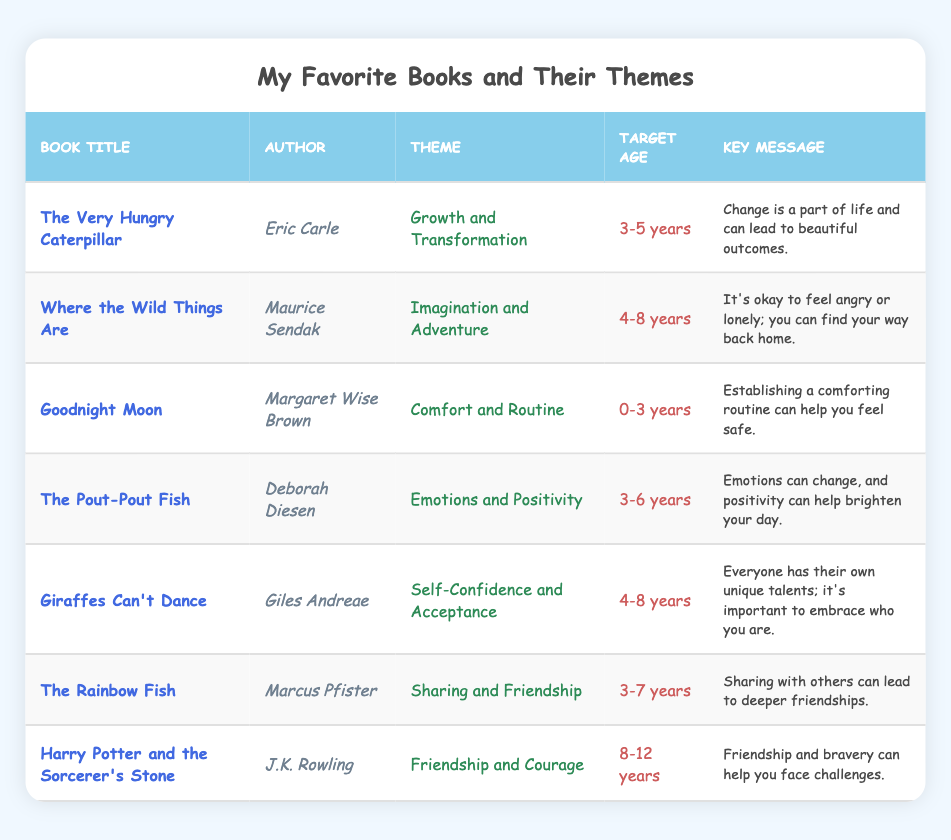What is the theme of "The Very Hungry Caterpillar"? The theme of "The Very Hungry Caterpillar" is found in the "Theme" column next to its title. It states "Growth and Transformation."
Answer: Growth and Transformation Who is the author of "Harry Potter and the Sorcerer's Stone"? To find the author, look at the row for "Harry Potter and the Sorcerer's Stone" and read the "Author" column, which shows "J.K. Rowling."
Answer: J.K. Rowling How many books are targeted for the age range of 4-8 years? By counting the rows that list "4-8 years" under the "Target Age" column, there are three books: "Where the Wild Things Are," "Giraffes Can't Dance," and "Harry Potter and the Sorcerer's Stone."
Answer: 3 Is the key message of "The Pout-Pout Fish" about sadness? The key message for "The Pout-Pout Fish" mentions positivity and changing emotions. It does not say sadness is the focus, so the answer is no.
Answer: No Which book has the theme of "Sharing and Friendship"? The row that mentions "Sharing and Friendship" in the "Theme" column corresponds to "The Rainbow Fish" in the "Book Title" column.
Answer: The Rainbow Fish What is the average target age of the books listed? To find the average, convert the target ages into numerical form (0-3 years = 1.5, 3-5 years = 4, 3-6 years = 4.5, 4-8 years = 6, 3-7 years = 5, 8-12 years = 10) and sum them: 1.5 + 4 + 4.5 + 4.5 + 6 + 5 + 10 = 36. Divide this by 7 (the number of books): 36 / 7 = 5.14 (approximately 5).
Answer: 5 Is "Goodnight Moon" aimed at children older than 3 years? The target age for "Goodnight Moon" is "0-3 years." Since it is not aimed at children older than 3, the answer is no.
Answer: No What books focus on emotions? To find books focusing on emotions, check the "Theme" column for mentions like "Emotions and Positivity." The relevant book is "The Pout-Pout Fish."
Answer: The Pout-Pout Fish How are the themes of "The Rainbow Fish" and "Giraffes Can't Dance" similar? Both books emphasize positive social interactions; "The Rainbow Fish" teaches about friendship through sharing, while "Giraffes Can't Dance" focuses on self-acceptance and confidence, which can enhance social relationships.
Answer: Both emphasize positive social interactions 